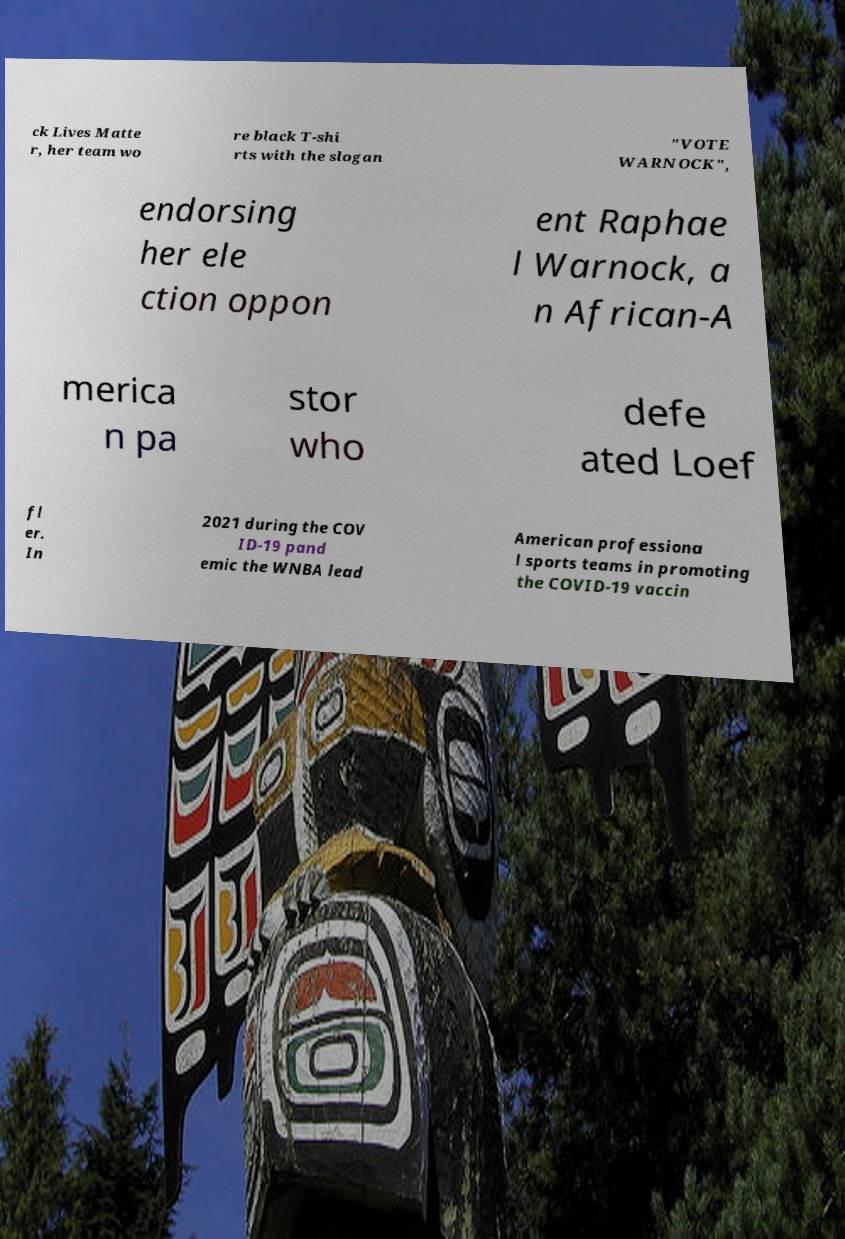There's text embedded in this image that I need extracted. Can you transcribe it verbatim? ck Lives Matte r, her team wo re black T-shi rts with the slogan "VOTE WARNOCK", endorsing her ele ction oppon ent Raphae l Warnock, a n African-A merica n pa stor who defe ated Loef fl er. In 2021 during the COV ID-19 pand emic the WNBA lead American professiona l sports teams in promoting the COVID-19 vaccin 